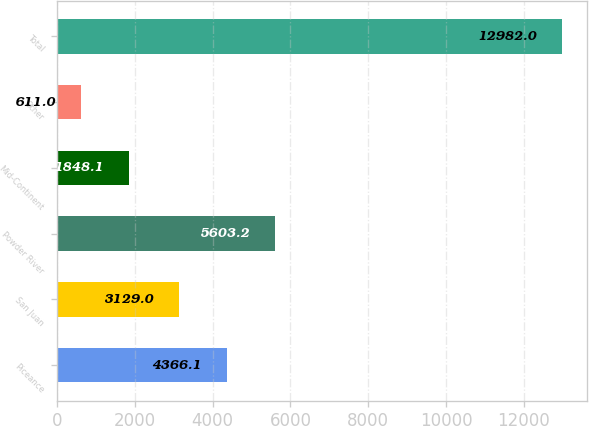Convert chart. <chart><loc_0><loc_0><loc_500><loc_500><bar_chart><fcel>Piceance<fcel>San Juan<fcel>Powder River<fcel>Mid-Continent<fcel>Other<fcel>Total<nl><fcel>4366.1<fcel>3129<fcel>5603.2<fcel>1848.1<fcel>611<fcel>12982<nl></chart> 